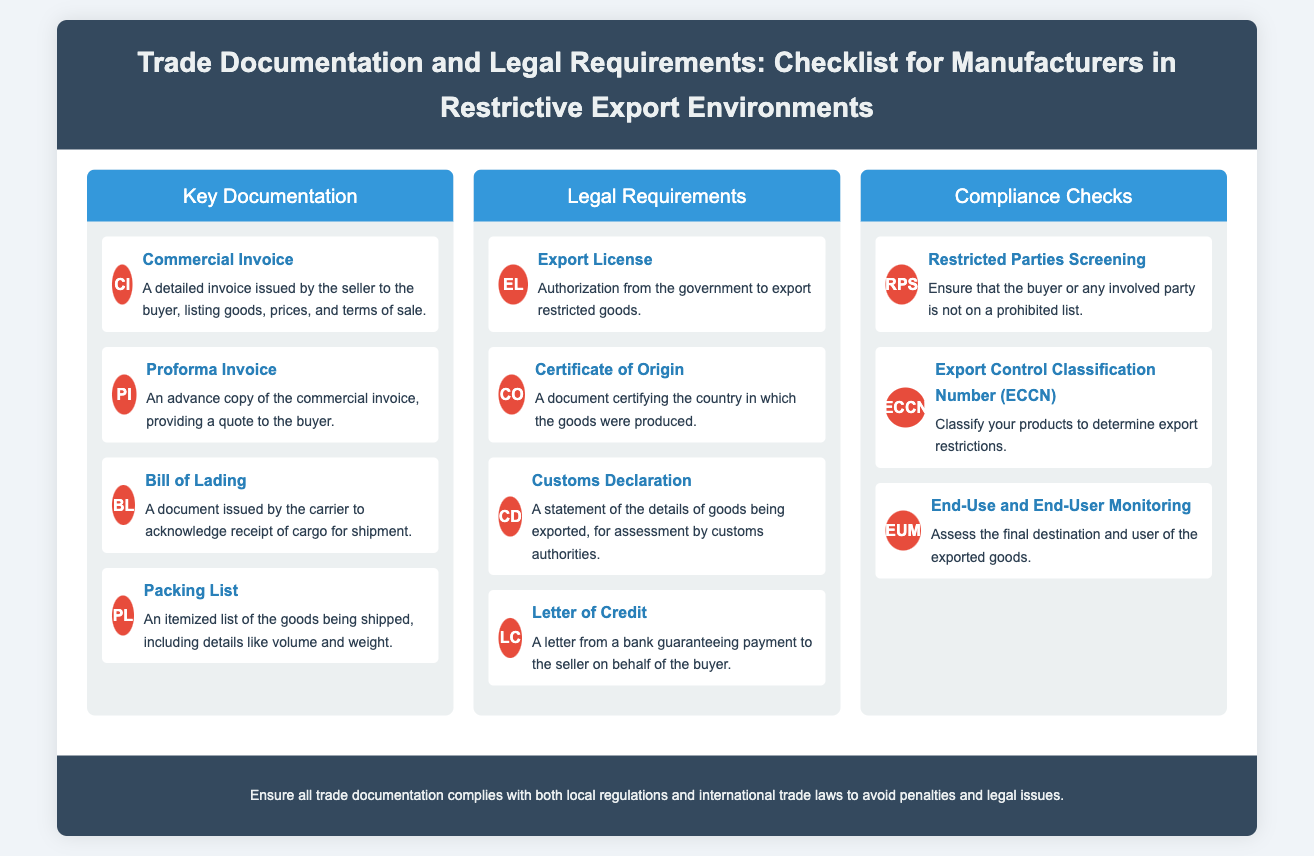what is the first key documentation item listed? The first key documentation item is identified in the section titled "Key Documentation," which is the Commercial Invoice.
Answer: Commercial Invoice how many legal requirements are mentioned? The number of legal requirements can be counted in the "Legal Requirements" section, which lists four items.
Answer: 4 what does "BL" stand for? The abbreviation "BL" is defined in the "Key Documentation" section next to the entry for Bill of Lading.
Answer: Bill of Lading name one compliance check required for restricted exports. The compliance checks can be found in the "Compliance Checks" section, where several items are listed. One of the items is Restricted Parties Screening.
Answer: Restricted Parties Screening what is the purpose of an Export License? The purpose of the Export License is explained in the entry under "Legal Requirements," indicating that it is authorization from the government to export restricted goods.
Answer: Authorization to export restricted goods which documentation item serves as an advance copy? The item serving as an advance copy is specified in the "Key Documentation" section, which is the Proforma Invoice.
Answer: Proforma Invoice how many items are in the Compliance Checks section? The number of items can be found by counting the entries listed under "Compliance Checks," which include three items.
Answer: 3 what is the color theme of the header in the infographic? The header color is indicated by the style elements described in the document structure, which notes a background color of #34495e.
Answer: Dark blue 